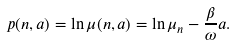Convert formula to latex. <formula><loc_0><loc_0><loc_500><loc_500>p ( n , a ) = \ln \mu ( n , a ) = \ln \mu _ { n } - \frac { \beta } { \omega } a .</formula> 